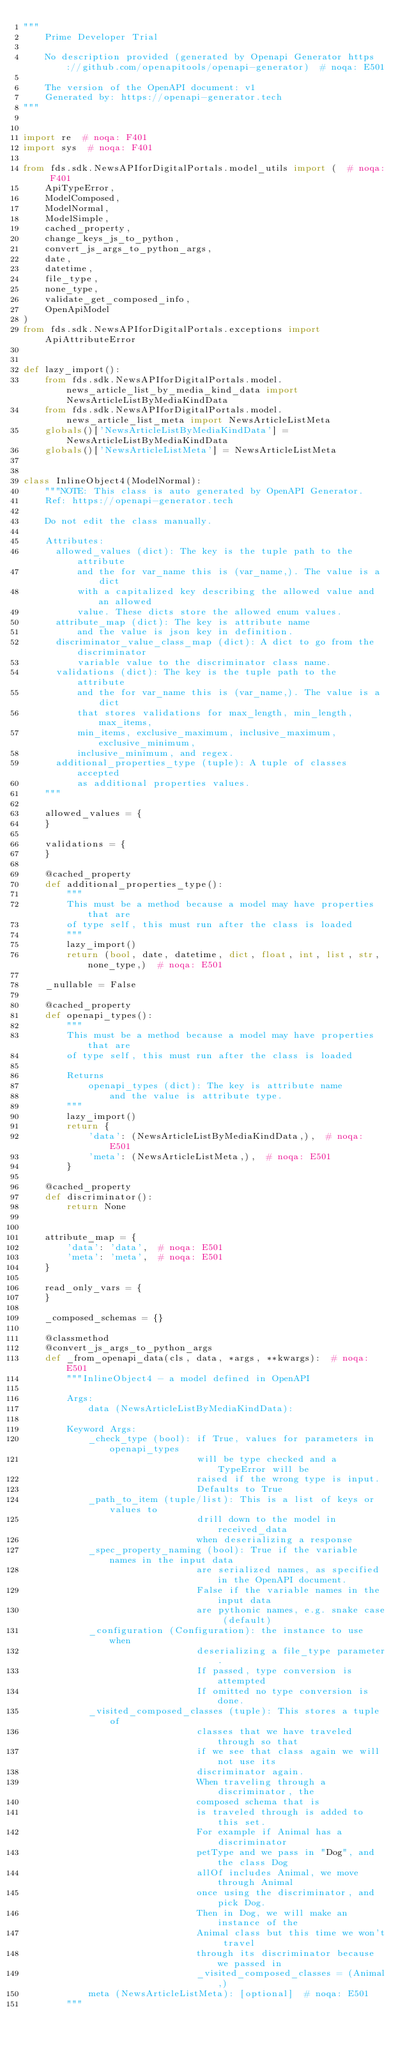<code> <loc_0><loc_0><loc_500><loc_500><_Python_>"""
    Prime Developer Trial

    No description provided (generated by Openapi Generator https://github.com/openapitools/openapi-generator)  # noqa: E501

    The version of the OpenAPI document: v1
    Generated by: https://openapi-generator.tech
"""


import re  # noqa: F401
import sys  # noqa: F401

from fds.sdk.NewsAPIforDigitalPortals.model_utils import (  # noqa: F401
    ApiTypeError,
    ModelComposed,
    ModelNormal,
    ModelSimple,
    cached_property,
    change_keys_js_to_python,
    convert_js_args_to_python_args,
    date,
    datetime,
    file_type,
    none_type,
    validate_get_composed_info,
    OpenApiModel
)
from fds.sdk.NewsAPIforDigitalPortals.exceptions import ApiAttributeError


def lazy_import():
    from fds.sdk.NewsAPIforDigitalPortals.model.news_article_list_by_media_kind_data import NewsArticleListByMediaKindData
    from fds.sdk.NewsAPIforDigitalPortals.model.news_article_list_meta import NewsArticleListMeta
    globals()['NewsArticleListByMediaKindData'] = NewsArticleListByMediaKindData
    globals()['NewsArticleListMeta'] = NewsArticleListMeta


class InlineObject4(ModelNormal):
    """NOTE: This class is auto generated by OpenAPI Generator.
    Ref: https://openapi-generator.tech

    Do not edit the class manually.

    Attributes:
      allowed_values (dict): The key is the tuple path to the attribute
          and the for var_name this is (var_name,). The value is a dict
          with a capitalized key describing the allowed value and an allowed
          value. These dicts store the allowed enum values.
      attribute_map (dict): The key is attribute name
          and the value is json key in definition.
      discriminator_value_class_map (dict): A dict to go from the discriminator
          variable value to the discriminator class name.
      validations (dict): The key is the tuple path to the attribute
          and the for var_name this is (var_name,). The value is a dict
          that stores validations for max_length, min_length, max_items,
          min_items, exclusive_maximum, inclusive_maximum, exclusive_minimum,
          inclusive_minimum, and regex.
      additional_properties_type (tuple): A tuple of classes accepted
          as additional properties values.
    """

    allowed_values = {
    }

    validations = {
    }

    @cached_property
    def additional_properties_type():
        """
        This must be a method because a model may have properties that are
        of type self, this must run after the class is loaded
        """
        lazy_import()
        return (bool, date, datetime, dict, float, int, list, str, none_type,)  # noqa: E501

    _nullable = False

    @cached_property
    def openapi_types():
        """
        This must be a method because a model may have properties that are
        of type self, this must run after the class is loaded

        Returns
            openapi_types (dict): The key is attribute name
                and the value is attribute type.
        """
        lazy_import()
        return {
            'data': (NewsArticleListByMediaKindData,),  # noqa: E501
            'meta': (NewsArticleListMeta,),  # noqa: E501
        }

    @cached_property
    def discriminator():
        return None


    attribute_map = {
        'data': 'data',  # noqa: E501
        'meta': 'meta',  # noqa: E501
    }

    read_only_vars = {
    }

    _composed_schemas = {}

    @classmethod
    @convert_js_args_to_python_args
    def _from_openapi_data(cls, data, *args, **kwargs):  # noqa: E501
        """InlineObject4 - a model defined in OpenAPI

        Args:
            data (NewsArticleListByMediaKindData):

        Keyword Args:
            _check_type (bool): if True, values for parameters in openapi_types
                                will be type checked and a TypeError will be
                                raised if the wrong type is input.
                                Defaults to True
            _path_to_item (tuple/list): This is a list of keys or values to
                                drill down to the model in received_data
                                when deserializing a response
            _spec_property_naming (bool): True if the variable names in the input data
                                are serialized names, as specified in the OpenAPI document.
                                False if the variable names in the input data
                                are pythonic names, e.g. snake case (default)
            _configuration (Configuration): the instance to use when
                                deserializing a file_type parameter.
                                If passed, type conversion is attempted
                                If omitted no type conversion is done.
            _visited_composed_classes (tuple): This stores a tuple of
                                classes that we have traveled through so that
                                if we see that class again we will not use its
                                discriminator again.
                                When traveling through a discriminator, the
                                composed schema that is
                                is traveled through is added to this set.
                                For example if Animal has a discriminator
                                petType and we pass in "Dog", and the class Dog
                                allOf includes Animal, we move through Animal
                                once using the discriminator, and pick Dog.
                                Then in Dog, we will make an instance of the
                                Animal class but this time we won't travel
                                through its discriminator because we passed in
                                _visited_composed_classes = (Animal,)
            meta (NewsArticleListMeta): [optional]  # noqa: E501
        """
</code> 